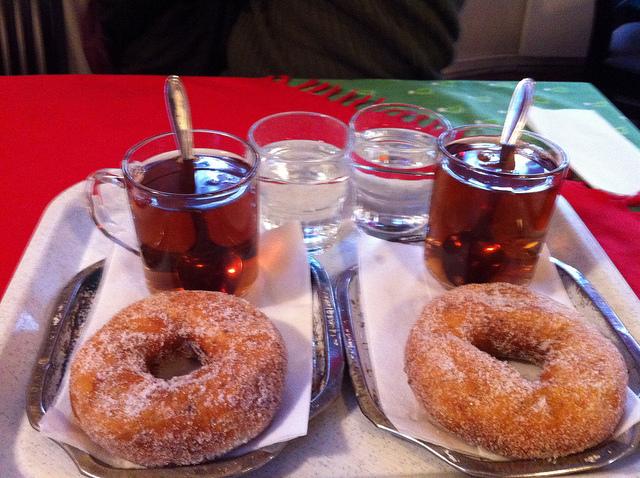How many donuts are pictured here?
Give a very brief answer. 2. What meal might these items be served at?
Write a very short answer. Breakfast. How many people are probably going to eat this food?
Give a very brief answer. 2. 